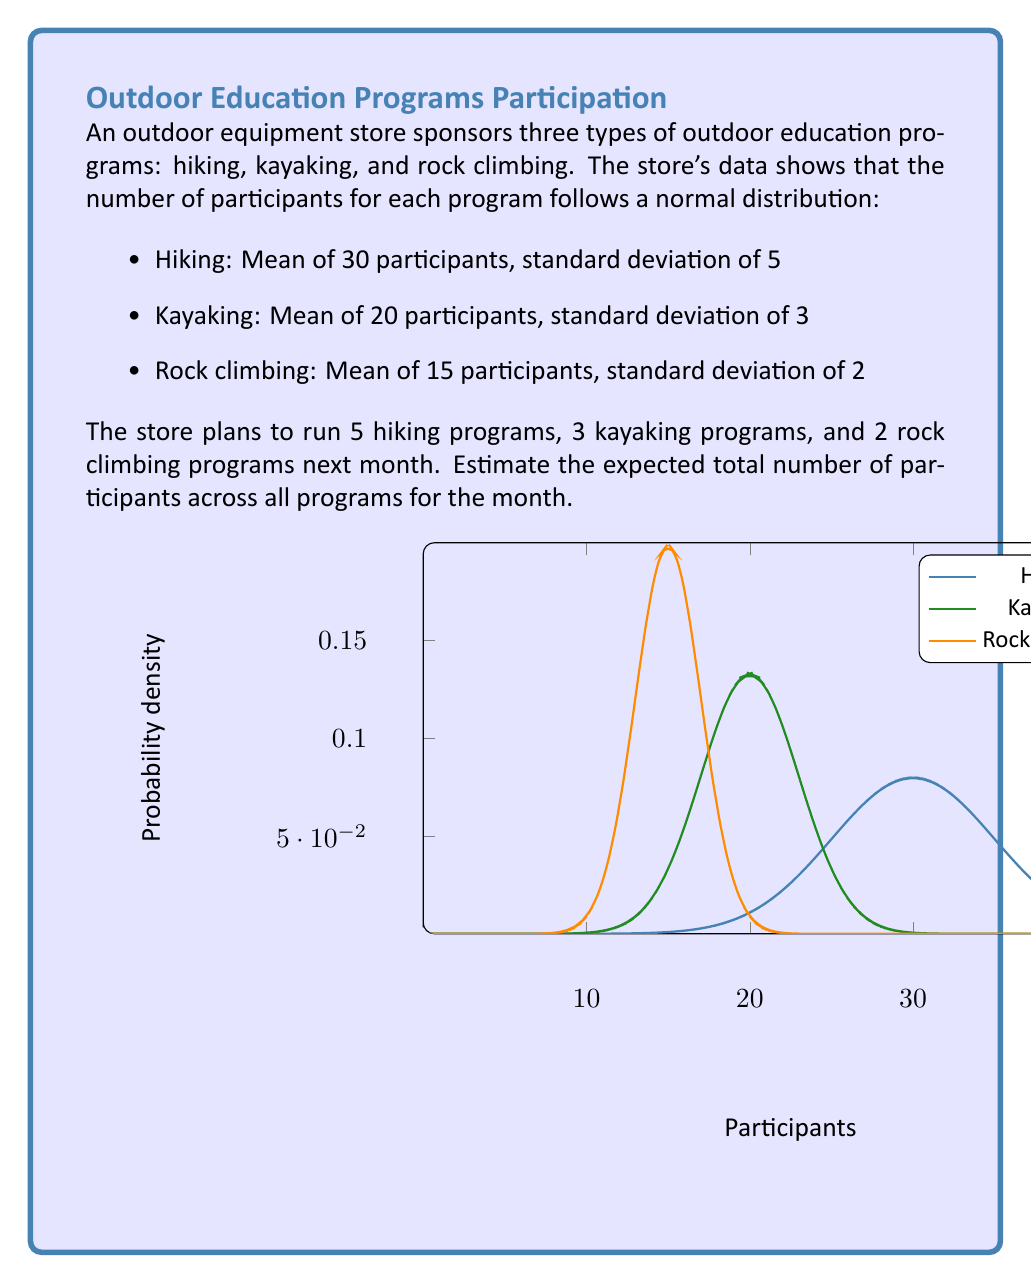Teach me how to tackle this problem. To solve this problem, we'll use the properties of expected value:

1) For a normal distribution, the expected value is equal to the mean.
2) The expected value of a sum is the sum of the expected values.

Let's calculate the expected number of participants for each program type:

1. Hiking:
   - Expected participants per program = 30
   - Number of programs = 5
   - Total expected participants = $30 \times 5 = 150$

2. Kayaking:
   - Expected participants per program = 20
   - Number of programs = 3
   - Total expected participants = $20 \times 3 = 60$

3. Rock climbing:
   - Expected participants per program = 15
   - Number of programs = 2
   - Total expected participants = $15 \times 2 = 30$

Now, we sum the expected participants from all programs:

$$\text{Total expected participants} = 150 + 60 + 30 = 240$$

Therefore, the expected total number of participants across all programs for the month is 240.

Note: We don't need to use the standard deviations in this calculation because we're only interested in the expected value, which is equal to the mean for a normal distribution.
Answer: 240 participants 